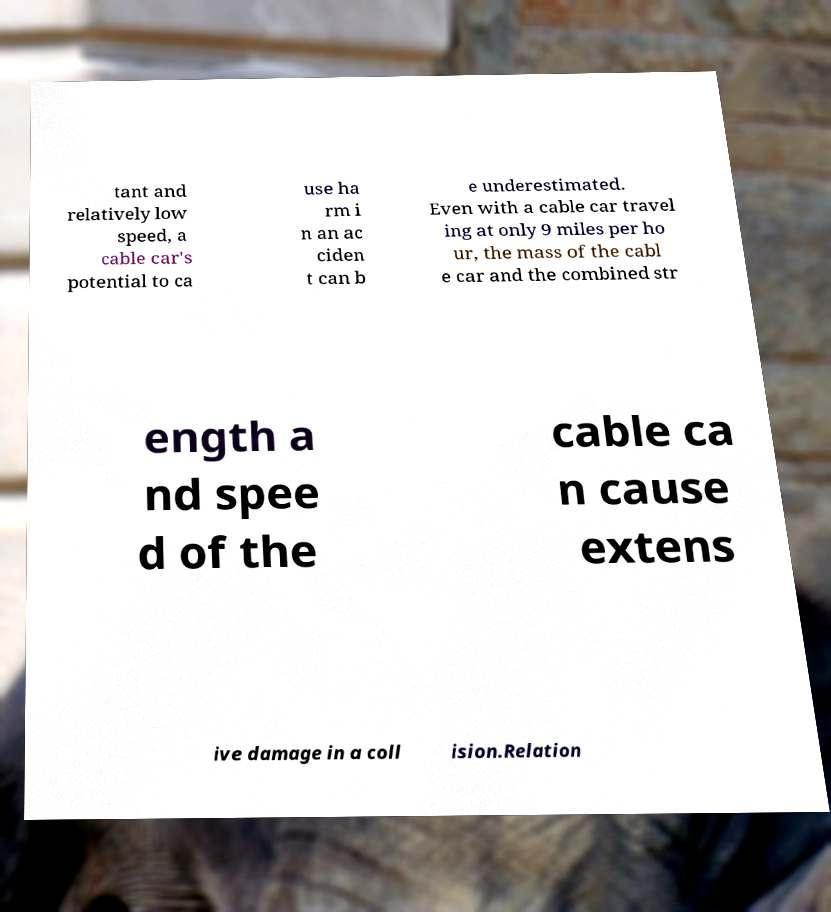Please identify and transcribe the text found in this image. tant and relatively low speed, a cable car's potential to ca use ha rm i n an ac ciden t can b e underestimated. Even with a cable car travel ing at only 9 miles per ho ur, the mass of the cabl e car and the combined str ength a nd spee d of the cable ca n cause extens ive damage in a coll ision.Relation 